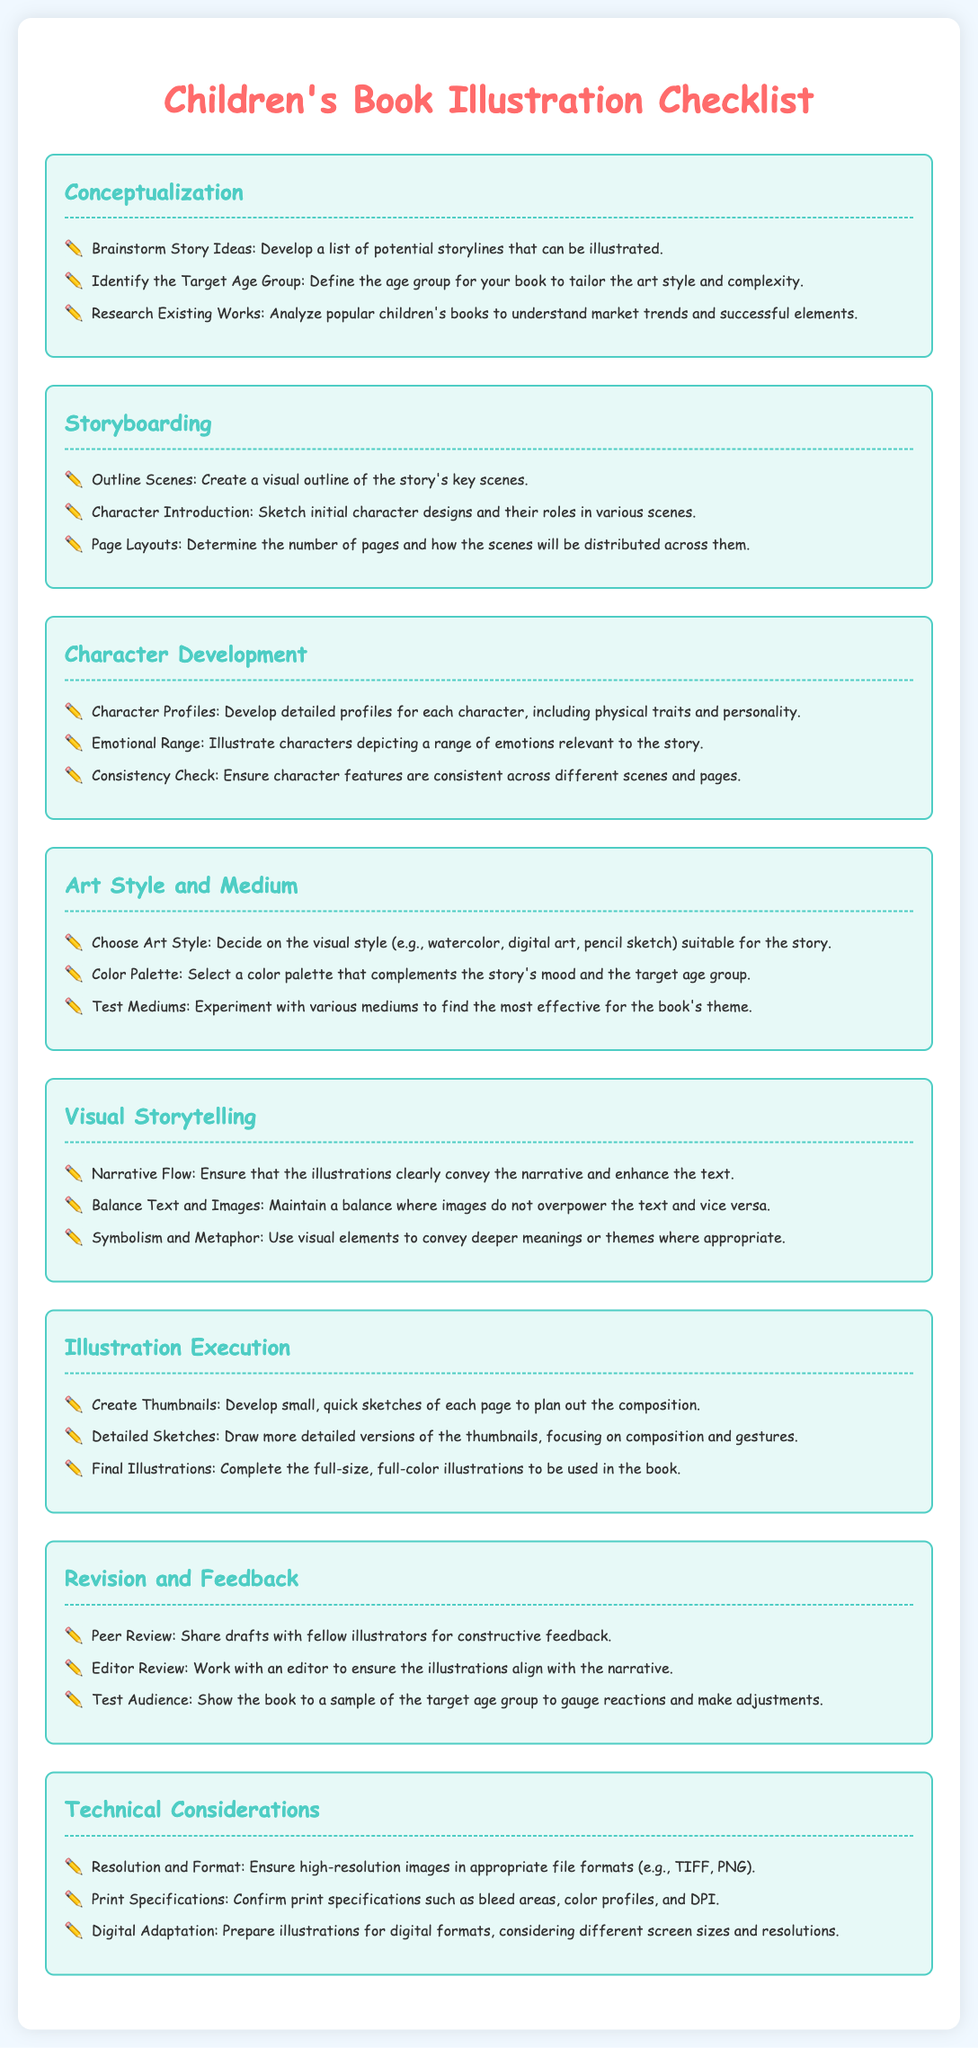What is the first step in the conceptualization phase? The first step is to brainstorm story ideas for illustration development.
Answer: Brainstorm story ideas What should be included in character profiles? Character profiles should include physical traits and personality details.
Answer: Physical traits and personality How many sections are there in the checklist? The checklist contains seven distinct sections.
Answer: Seven What is the focus of the visual storytelling section? The focus is on ensuring the illustrations convey the narrative and enhance the text.
Answer: Convey the narrative Which art styles can be chosen for the illustrations? Examples include watercolor, digital art, and pencil sketch.
Answer: Watercolor, digital art, pencil sketch What is tested during the revision and feedback stage? The book is shown to a sample of the target age group to gauge reactions.
Answer: Sample of the target age group What resolution type is required for illustrations? High-resolution images are needed in appropriate file formats.
Answer: High-resolution images What is a key element in maintaining the balance of text and images? The balance is where images do not overpower the text and vice versa.
Answer: Do not overpower the text 